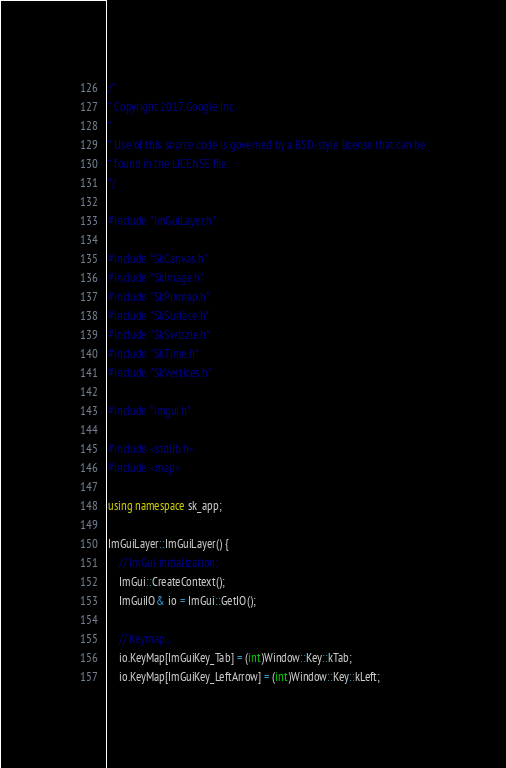<code> <loc_0><loc_0><loc_500><loc_500><_C++_>/*
* Copyright 2017 Google Inc.
*
* Use of this source code is governed by a BSD-style license that can be
* found in the LICENSE file.
*/

#include "ImGuiLayer.h"

#include "SkCanvas.h"
#include "SkImage.h"
#include "SkPixmap.h"
#include "SkSurface.h"
#include "SkSwizzle.h"
#include "SkTime.h"
#include "SkVertices.h"

#include "imgui.h"

#include <stdlib.h>
#include <map>

using namespace sk_app;

ImGuiLayer::ImGuiLayer() {
    // ImGui initialization:
    ImGui::CreateContext();
    ImGuiIO& io = ImGui::GetIO();

    // Keymap...
    io.KeyMap[ImGuiKey_Tab] = (int)Window::Key::kTab;
    io.KeyMap[ImGuiKey_LeftArrow] = (int)Window::Key::kLeft;</code> 